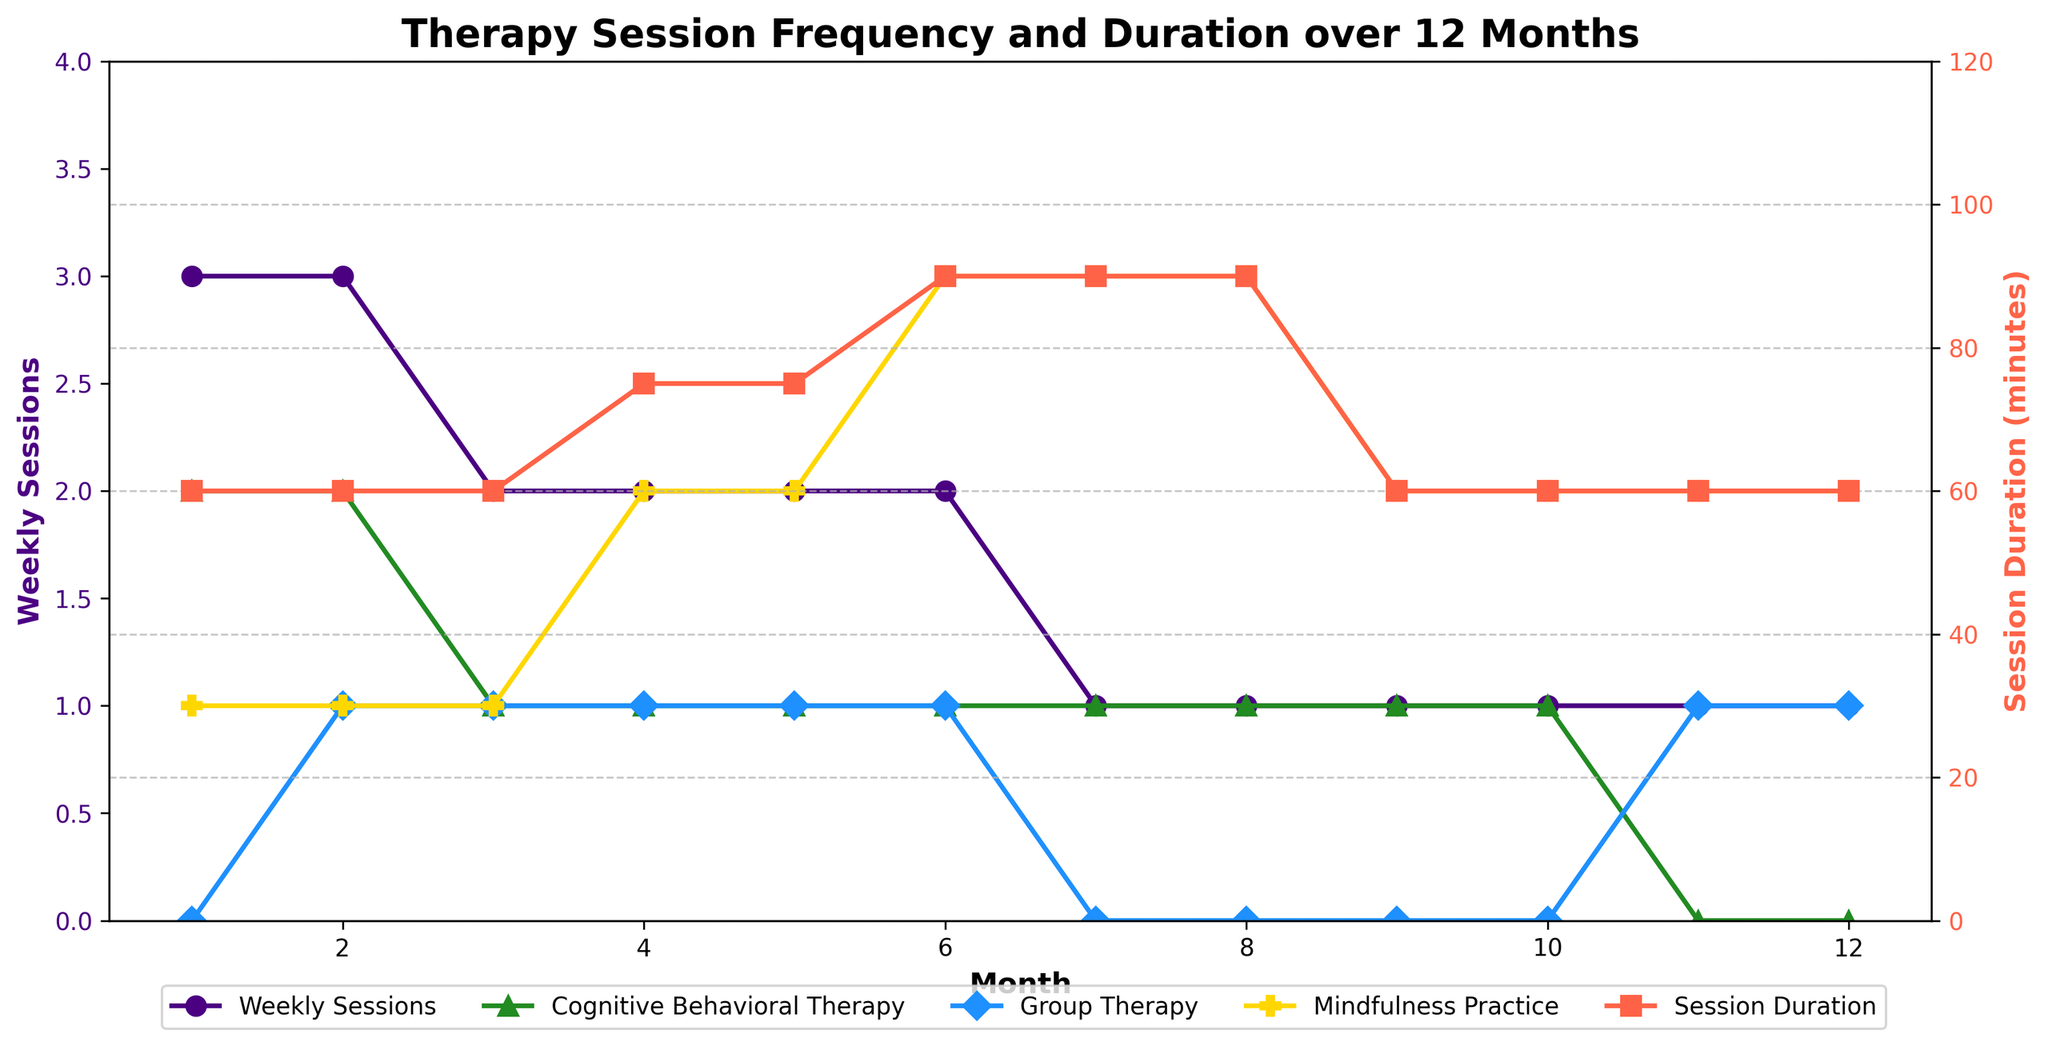What is the total number of Cognitive Behavioral Therapy sessions in the first 6 months? Sum the data points for Cognitive Behavioral Therapy from months 1 to 6: 2 + 2 + 1 + 1 + 1 + 1 = 8
Answer: 8 How does the frequency of weekly sessions change from month 1 to month 12? Initially, the weekly sessions start at 3 in month 1, then decrease to 2 from months 3 to 6, and finally drop to 1 from month 7 to month 12
Answer: Decreases Which month has the highest average session duration, and what is it? Check the session duration column and find the highest value or values: Months 6, 7, and 8 have the highest durations, all at 90 minutes
Answer: Months 6, 7, 8; 90 minutes How many months had more than one type of therapy session? Count the months where more than one therapy type is greater than 0:
Months: 2 (CBT and Group), 3 (CBT, Group, Mindfulness), 4 (CBT, Group, Mindfulness), 5 (CBT, Group, Mindfulness), 6 (CBT, Group, Mindfulness), 11 (Group, Mindfulness), 12 (Group, Mindfulness) → 7
Answer: 7 What visual trends can be observed regarding 'Mindfulness Practice' session frequency over the 12 months? The frequency slowly increases from months 1 to 6, remains steady from months 7 to 8, and then decreases slightly from months 9 to 12
Answer: Increases initially, plateaus, then decreases In which month is there no Cognitive Behavioral Therapy session? Look for zeros in the Cognitive Behavioral Therapy row: Months 11 and 12
Answer: Months 11 and 12 Compare the weekly sessions in month 3 and month 7. Which month has more weekly sessions? Weekly sessions are 2 in month 3 and 1 in month 7
Answer: Month 3 Calculate the average session duration for the entire period. Average = (60+60+60+75+75+90+90+90+60+60+60+60) / 12 = 66.25 minutes
Answer: 66.25 minutes What is the relationship between session duration and the frequency of weekly sessions? Longer session durations (90 minutes) tend to occur when the frequency of weekly sessions is fewer (1 session per week), especially in months 6, 7, and 8
Answer: Inversely related Which specific months had more Group Therapy sessions compared to the previous month? Compare the Group Therapy frequency between consecutive months: Month 2 (1 > 0), Month 6 (1 > 0)
Answer: Months 2, 6 